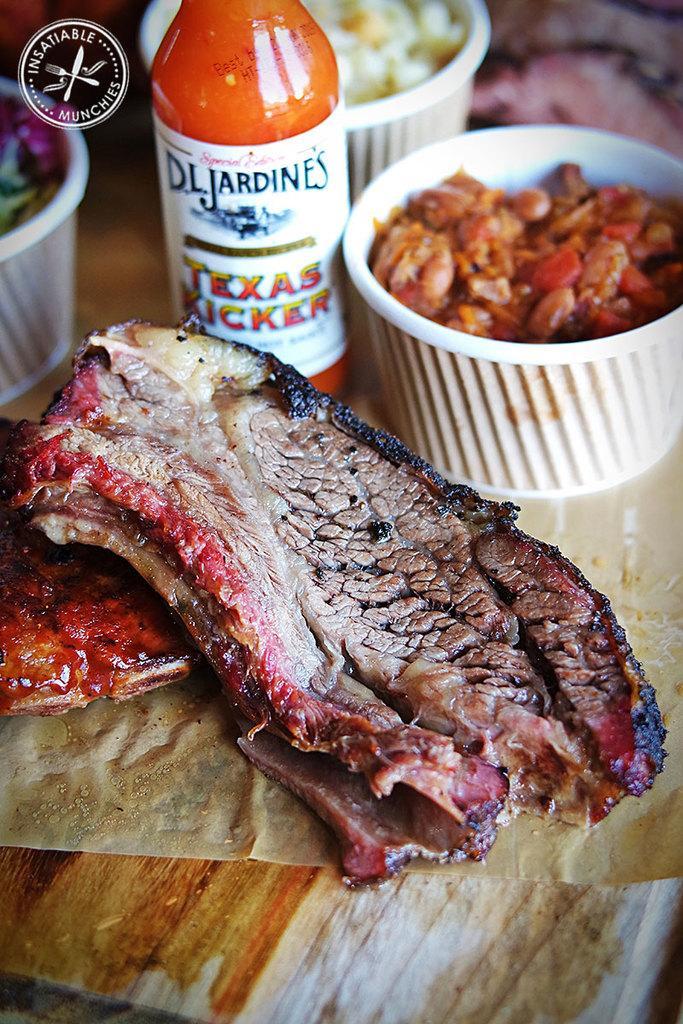Could you give a brief overview of what you see in this image? In this image there are many food items kept on a table. There is a meat and around that there are three bowls of other food items and in between them there is a bottle. 